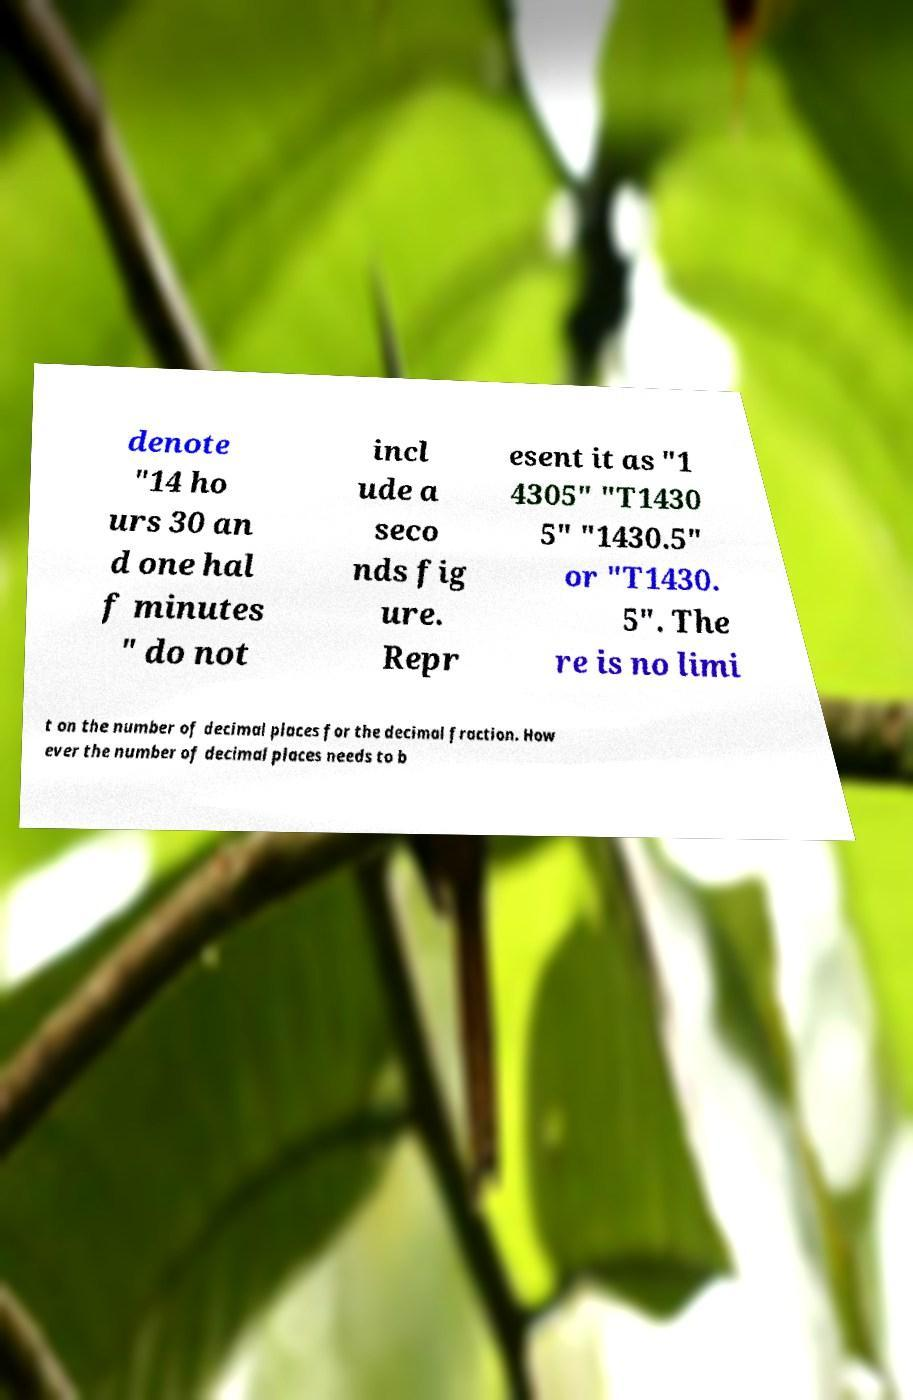There's text embedded in this image that I need extracted. Can you transcribe it verbatim? denote "14 ho urs 30 an d one hal f minutes " do not incl ude a seco nds fig ure. Repr esent it as "1 4305" "T1430 5" "1430.5" or "T1430. 5". The re is no limi t on the number of decimal places for the decimal fraction. How ever the number of decimal places needs to b 